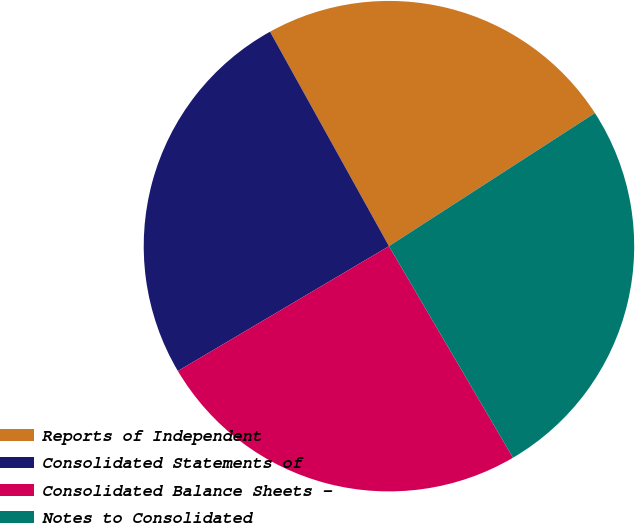Convert chart. <chart><loc_0><loc_0><loc_500><loc_500><pie_chart><fcel>Reports of Independent<fcel>Consolidated Statements of<fcel>Consolidated Balance Sheets -<fcel>Notes to Consolidated<nl><fcel>23.93%<fcel>25.44%<fcel>24.94%<fcel>25.69%<nl></chart> 